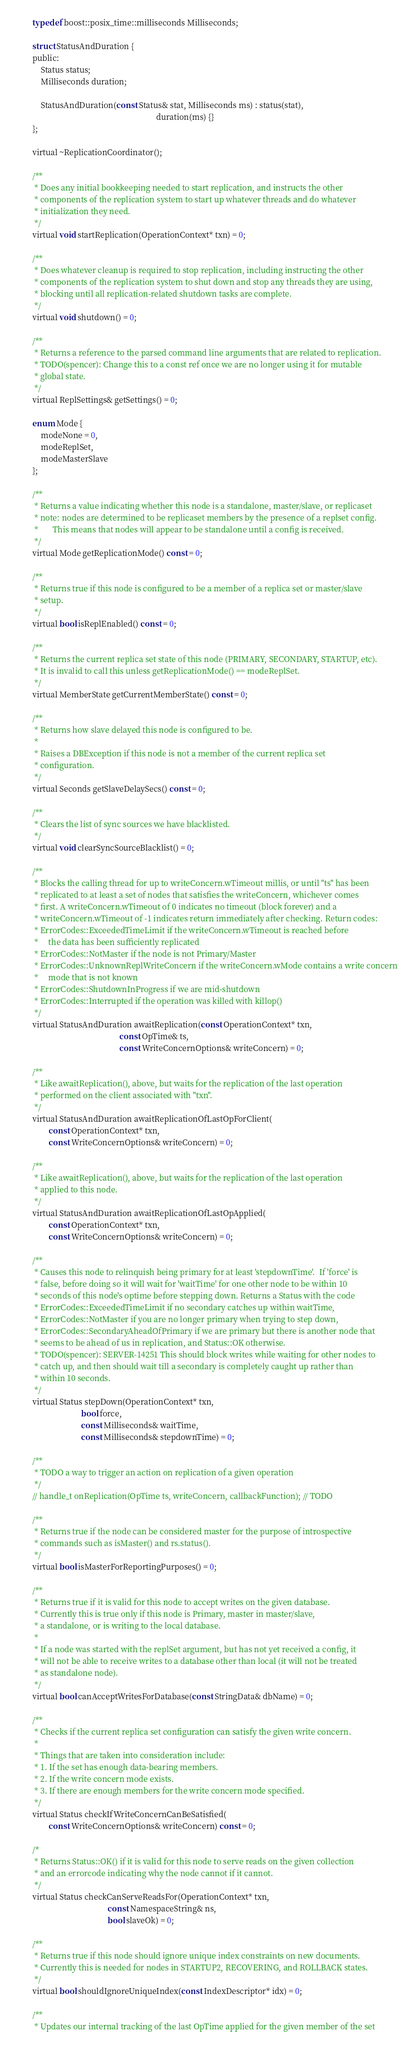Convert code to text. <code><loc_0><loc_0><loc_500><loc_500><_C_>
        typedef boost::posix_time::milliseconds Milliseconds;

        struct StatusAndDuration {
        public:
            Status status;
            Milliseconds duration;

            StatusAndDuration(const Status& stat, Milliseconds ms) : status(stat),
                                                                     duration(ms) {}
        };

        virtual ~ReplicationCoordinator();

        /**
         * Does any initial bookkeeping needed to start replication, and instructs the other
         * components of the replication system to start up whatever threads and do whatever
         * initialization they need.
         */
        virtual void startReplication(OperationContext* txn) = 0;

        /**
         * Does whatever cleanup is required to stop replication, including instructing the other
         * components of the replication system to shut down and stop any threads they are using,
         * blocking until all replication-related shutdown tasks are complete.
         */
        virtual void shutdown() = 0;

        /**
         * Returns a reference to the parsed command line arguments that are related to replication.
         * TODO(spencer): Change this to a const ref once we are no longer using it for mutable
         * global state.
         */
        virtual ReplSettings& getSettings() = 0;

        enum Mode {
            modeNone = 0,
            modeReplSet,
            modeMasterSlave
        };

        /**
         * Returns a value indicating whether this node is a standalone, master/slave, or replicaset
         * note: nodes are determined to be replicaset members by the presence of a replset config.
         *       This means that nodes will appear to be standalone until a config is received.
         */
        virtual Mode getReplicationMode() const = 0;

        /**
         * Returns true if this node is configured to be a member of a replica set or master/slave
         * setup.
         */
        virtual bool isReplEnabled() const = 0;

        /**
         * Returns the current replica set state of this node (PRIMARY, SECONDARY, STARTUP, etc).
         * It is invalid to call this unless getReplicationMode() == modeReplSet.
         */
        virtual MemberState getCurrentMemberState() const = 0;

        /**
         * Returns how slave delayed this node is configured to be.
         *
         * Raises a DBException if this node is not a member of the current replica set
         * configuration.
         */
        virtual Seconds getSlaveDelaySecs() const = 0;

        /**
         * Clears the list of sync sources we have blacklisted.
         */
        virtual void clearSyncSourceBlacklist() = 0;

        /**
         * Blocks the calling thread for up to writeConcern.wTimeout millis, or until "ts" has been
         * replicated to at least a set of nodes that satisfies the writeConcern, whichever comes
         * first. A writeConcern.wTimeout of 0 indicates no timeout (block forever) and a
         * writeConcern.wTimeout of -1 indicates return immediately after checking. Return codes:
         * ErrorCodes::ExceededTimeLimit if the writeConcern.wTimeout is reached before
         *     the data has been sufficiently replicated
         * ErrorCodes::NotMaster if the node is not Primary/Master
         * ErrorCodes::UnknownReplWriteConcern if the writeConcern.wMode contains a write concern
         *     mode that is not known
         * ErrorCodes::ShutdownInProgress if we are mid-shutdown
         * ErrorCodes::Interrupted if the operation was killed with killop()
         */
        virtual StatusAndDuration awaitReplication(const OperationContext* txn,
                                                   const OpTime& ts,
                                                   const WriteConcernOptions& writeConcern) = 0;

        /**
         * Like awaitReplication(), above, but waits for the replication of the last operation
         * performed on the client associated with "txn".
         */
        virtual StatusAndDuration awaitReplicationOfLastOpForClient(
                const OperationContext* txn,
                const WriteConcernOptions& writeConcern) = 0;

        /**
         * Like awaitReplication(), above, but waits for the replication of the last operation
         * applied to this node.
         */
        virtual StatusAndDuration awaitReplicationOfLastOpApplied(
                const OperationContext* txn,
                const WriteConcernOptions& writeConcern) = 0;

        /**
         * Causes this node to relinquish being primary for at least 'stepdownTime'.  If 'force' is
         * false, before doing so it will wait for 'waitTime' for one other node to be within 10
         * seconds of this node's optime before stepping down. Returns a Status with the code
         * ErrorCodes::ExceededTimeLimit if no secondary catches up within waitTime,
         * ErrorCodes::NotMaster if you are no longer primary when trying to step down,
         * ErrorCodes::SecondaryAheadOfPrimary if we are primary but there is another node that
         * seems to be ahead of us in replication, and Status::OK otherwise.
         * TODO(spencer): SERVER-14251 This should block writes while waiting for other nodes to
         * catch up, and then should wait till a secondary is completely caught up rather than
         * within 10 seconds.
         */
        virtual Status stepDown(OperationContext* txn,
                                bool force,
                                const Milliseconds& waitTime,
                                const Milliseconds& stepdownTime) = 0;

        /**
         * TODO a way to trigger an action on replication of a given operation
         */
        // handle_t onReplication(OpTime ts, writeConcern, callbackFunction); // TODO

        /**
         * Returns true if the node can be considered master for the purpose of introspective
         * commands such as isMaster() and rs.status().
         */
        virtual bool isMasterForReportingPurposes() = 0;

        /**
         * Returns true if it is valid for this node to accept writes on the given database.
         * Currently this is true only if this node is Primary, master in master/slave,
         * a standalone, or is writing to the local database.
         *
         * If a node was started with the replSet argument, but has not yet received a config, it
         * will not be able to receive writes to a database other than local (it will not be treated
         * as standalone node).
         */
        virtual bool canAcceptWritesForDatabase(const StringData& dbName) = 0;

        /**
         * Checks if the current replica set configuration can satisfy the given write concern.
         *
         * Things that are taken into consideration include:
         * 1. If the set has enough data-bearing members.
         * 2. If the write concern mode exists.
         * 3. If there are enough members for the write concern mode specified.
         */
        virtual Status checkIfWriteConcernCanBeSatisfied(
                const WriteConcernOptions& writeConcern) const = 0;

        /*
         * Returns Status::OK() if it is valid for this node to serve reads on the given collection
         * and an errorcode indicating why the node cannot if it cannot.
         */
        virtual Status checkCanServeReadsFor(OperationContext* txn,
                                             const NamespaceString& ns,
                                             bool slaveOk) = 0;

        /**
         * Returns true if this node should ignore unique index constraints on new documents.
         * Currently this is needed for nodes in STARTUP2, RECOVERING, and ROLLBACK states.
         */
        virtual bool shouldIgnoreUniqueIndex(const IndexDescriptor* idx) = 0;

        /**
         * Updates our internal tracking of the last OpTime applied for the given member of the set</code> 